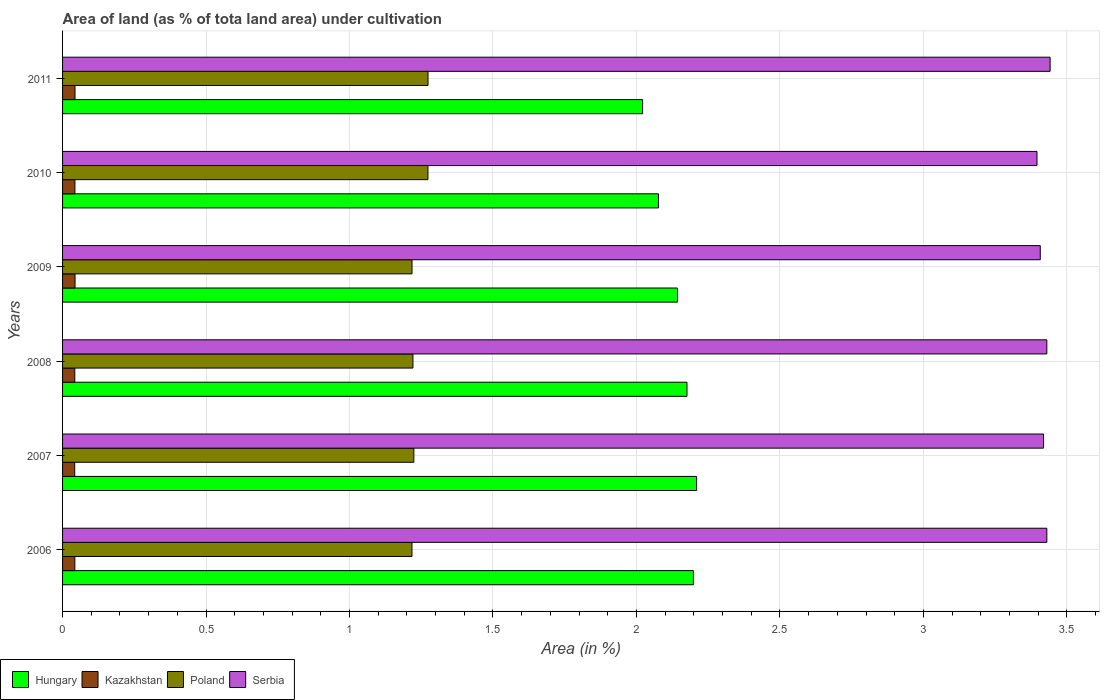How many groups of bars are there?
Ensure brevity in your answer.  6. Are the number of bars per tick equal to the number of legend labels?
Make the answer very short. Yes. How many bars are there on the 2nd tick from the top?
Offer a terse response. 4. What is the label of the 2nd group of bars from the top?
Offer a terse response. 2010. In how many cases, is the number of bars for a given year not equal to the number of legend labels?
Your answer should be compact. 0. What is the percentage of land under cultivation in Poland in 2009?
Make the answer very short. 1.22. Across all years, what is the maximum percentage of land under cultivation in Kazakhstan?
Provide a succinct answer. 0.04. Across all years, what is the minimum percentage of land under cultivation in Hungary?
Offer a very short reply. 2.02. In which year was the percentage of land under cultivation in Hungary maximum?
Your response must be concise. 2007. What is the total percentage of land under cultivation in Hungary in the graph?
Offer a terse response. 12.83. What is the difference between the percentage of land under cultivation in Hungary in 2006 and that in 2009?
Provide a short and direct response. 0.06. What is the difference between the percentage of land under cultivation in Serbia in 2006 and the percentage of land under cultivation in Kazakhstan in 2007?
Your response must be concise. 3.39. What is the average percentage of land under cultivation in Poland per year?
Your response must be concise. 1.24. In the year 2007, what is the difference between the percentage of land under cultivation in Poland and percentage of land under cultivation in Kazakhstan?
Your answer should be compact. 1.18. In how many years, is the percentage of land under cultivation in Kazakhstan greater than 0.5 %?
Your response must be concise. 0. What is the ratio of the percentage of land under cultivation in Serbia in 2008 to that in 2010?
Make the answer very short. 1.01. Is the difference between the percentage of land under cultivation in Poland in 2006 and 2009 greater than the difference between the percentage of land under cultivation in Kazakhstan in 2006 and 2009?
Your answer should be compact. Yes. What is the difference between the highest and the second highest percentage of land under cultivation in Kazakhstan?
Provide a short and direct response. 7.408230544130034e-5. What is the difference between the highest and the lowest percentage of land under cultivation in Serbia?
Ensure brevity in your answer.  0.05. Is the sum of the percentage of land under cultivation in Hungary in 2007 and 2008 greater than the maximum percentage of land under cultivation in Poland across all years?
Your answer should be very brief. Yes. What does the 2nd bar from the top in 2007 represents?
Make the answer very short. Poland. What does the 1st bar from the bottom in 2008 represents?
Ensure brevity in your answer.  Hungary. Is it the case that in every year, the sum of the percentage of land under cultivation in Kazakhstan and percentage of land under cultivation in Serbia is greater than the percentage of land under cultivation in Hungary?
Make the answer very short. Yes. How many years are there in the graph?
Give a very brief answer. 6. Does the graph contain any zero values?
Provide a succinct answer. No. How many legend labels are there?
Offer a terse response. 4. How are the legend labels stacked?
Give a very brief answer. Horizontal. What is the title of the graph?
Offer a very short reply. Area of land (as % of tota land area) under cultivation. What is the label or title of the X-axis?
Keep it short and to the point. Area (in %). What is the Area (in %) of Hungary in 2006?
Your answer should be very brief. 2.2. What is the Area (in %) in Kazakhstan in 2006?
Provide a short and direct response. 0.04. What is the Area (in %) of Poland in 2006?
Keep it short and to the point. 1.22. What is the Area (in %) in Serbia in 2006?
Offer a very short reply. 3.43. What is the Area (in %) of Hungary in 2007?
Offer a very short reply. 2.21. What is the Area (in %) of Kazakhstan in 2007?
Provide a short and direct response. 0.04. What is the Area (in %) of Poland in 2007?
Your response must be concise. 1.22. What is the Area (in %) of Serbia in 2007?
Your answer should be compact. 3.42. What is the Area (in %) in Hungary in 2008?
Your answer should be compact. 2.18. What is the Area (in %) of Kazakhstan in 2008?
Make the answer very short. 0.04. What is the Area (in %) in Poland in 2008?
Your answer should be very brief. 1.22. What is the Area (in %) of Serbia in 2008?
Offer a terse response. 3.43. What is the Area (in %) of Hungary in 2009?
Your answer should be compact. 2.14. What is the Area (in %) of Kazakhstan in 2009?
Offer a terse response. 0.04. What is the Area (in %) of Poland in 2009?
Provide a succinct answer. 1.22. What is the Area (in %) of Serbia in 2009?
Your response must be concise. 3.41. What is the Area (in %) of Hungary in 2010?
Make the answer very short. 2.08. What is the Area (in %) in Kazakhstan in 2010?
Your response must be concise. 0.04. What is the Area (in %) of Poland in 2010?
Your response must be concise. 1.27. What is the Area (in %) in Serbia in 2010?
Keep it short and to the point. 3.4. What is the Area (in %) in Hungary in 2011?
Offer a very short reply. 2.02. What is the Area (in %) in Kazakhstan in 2011?
Keep it short and to the point. 0.04. What is the Area (in %) of Poland in 2011?
Make the answer very short. 1.27. What is the Area (in %) in Serbia in 2011?
Provide a short and direct response. 3.44. Across all years, what is the maximum Area (in %) in Hungary?
Give a very brief answer. 2.21. Across all years, what is the maximum Area (in %) in Kazakhstan?
Provide a short and direct response. 0.04. Across all years, what is the maximum Area (in %) in Poland?
Ensure brevity in your answer.  1.27. Across all years, what is the maximum Area (in %) of Serbia?
Your answer should be very brief. 3.44. Across all years, what is the minimum Area (in %) of Hungary?
Your response must be concise. 2.02. Across all years, what is the minimum Area (in %) in Kazakhstan?
Provide a short and direct response. 0.04. Across all years, what is the minimum Area (in %) of Poland?
Your answer should be very brief. 1.22. Across all years, what is the minimum Area (in %) of Serbia?
Give a very brief answer. 3.4. What is the total Area (in %) in Hungary in the graph?
Your response must be concise. 12.83. What is the total Area (in %) of Kazakhstan in the graph?
Offer a terse response. 0.26. What is the total Area (in %) of Poland in the graph?
Your response must be concise. 7.43. What is the total Area (in %) of Serbia in the graph?
Your response must be concise. 20.52. What is the difference between the Area (in %) of Hungary in 2006 and that in 2007?
Your answer should be compact. -0.01. What is the difference between the Area (in %) of Poland in 2006 and that in 2007?
Your answer should be compact. -0.01. What is the difference between the Area (in %) in Serbia in 2006 and that in 2007?
Give a very brief answer. 0.01. What is the difference between the Area (in %) of Hungary in 2006 and that in 2008?
Keep it short and to the point. 0.02. What is the difference between the Area (in %) of Poland in 2006 and that in 2008?
Make the answer very short. -0. What is the difference between the Area (in %) in Hungary in 2006 and that in 2009?
Make the answer very short. 0.06. What is the difference between the Area (in %) of Kazakhstan in 2006 and that in 2009?
Make the answer very short. -0. What is the difference between the Area (in %) of Poland in 2006 and that in 2009?
Give a very brief answer. -0. What is the difference between the Area (in %) of Serbia in 2006 and that in 2009?
Make the answer very short. 0.02. What is the difference between the Area (in %) in Hungary in 2006 and that in 2010?
Keep it short and to the point. 0.12. What is the difference between the Area (in %) of Kazakhstan in 2006 and that in 2010?
Provide a short and direct response. -0. What is the difference between the Area (in %) of Poland in 2006 and that in 2010?
Ensure brevity in your answer.  -0.06. What is the difference between the Area (in %) of Serbia in 2006 and that in 2010?
Make the answer very short. 0.03. What is the difference between the Area (in %) of Hungary in 2006 and that in 2011?
Your response must be concise. 0.18. What is the difference between the Area (in %) of Kazakhstan in 2006 and that in 2011?
Offer a very short reply. -0. What is the difference between the Area (in %) of Poland in 2006 and that in 2011?
Provide a succinct answer. -0.06. What is the difference between the Area (in %) of Serbia in 2006 and that in 2011?
Keep it short and to the point. -0.01. What is the difference between the Area (in %) in Hungary in 2007 and that in 2008?
Your answer should be compact. 0.03. What is the difference between the Area (in %) in Kazakhstan in 2007 and that in 2008?
Provide a succinct answer. -0. What is the difference between the Area (in %) in Poland in 2007 and that in 2008?
Ensure brevity in your answer.  0. What is the difference between the Area (in %) in Serbia in 2007 and that in 2008?
Your answer should be compact. -0.01. What is the difference between the Area (in %) in Hungary in 2007 and that in 2009?
Keep it short and to the point. 0.07. What is the difference between the Area (in %) of Kazakhstan in 2007 and that in 2009?
Provide a succinct answer. -0. What is the difference between the Area (in %) of Poland in 2007 and that in 2009?
Offer a terse response. 0.01. What is the difference between the Area (in %) of Serbia in 2007 and that in 2009?
Give a very brief answer. 0.01. What is the difference between the Area (in %) in Hungary in 2007 and that in 2010?
Your answer should be very brief. 0.13. What is the difference between the Area (in %) of Kazakhstan in 2007 and that in 2010?
Offer a very short reply. -0. What is the difference between the Area (in %) of Poland in 2007 and that in 2010?
Make the answer very short. -0.05. What is the difference between the Area (in %) of Serbia in 2007 and that in 2010?
Your answer should be compact. 0.02. What is the difference between the Area (in %) of Hungary in 2007 and that in 2011?
Keep it short and to the point. 0.19. What is the difference between the Area (in %) in Kazakhstan in 2007 and that in 2011?
Provide a short and direct response. -0. What is the difference between the Area (in %) in Poland in 2007 and that in 2011?
Keep it short and to the point. -0.05. What is the difference between the Area (in %) of Serbia in 2007 and that in 2011?
Make the answer very short. -0.02. What is the difference between the Area (in %) of Hungary in 2008 and that in 2009?
Provide a succinct answer. 0.03. What is the difference between the Area (in %) of Kazakhstan in 2008 and that in 2009?
Keep it short and to the point. -0. What is the difference between the Area (in %) of Poland in 2008 and that in 2009?
Your response must be concise. 0. What is the difference between the Area (in %) in Serbia in 2008 and that in 2009?
Give a very brief answer. 0.02. What is the difference between the Area (in %) of Hungary in 2008 and that in 2010?
Keep it short and to the point. 0.1. What is the difference between the Area (in %) in Kazakhstan in 2008 and that in 2010?
Give a very brief answer. -0. What is the difference between the Area (in %) of Poland in 2008 and that in 2010?
Give a very brief answer. -0.05. What is the difference between the Area (in %) of Serbia in 2008 and that in 2010?
Offer a very short reply. 0.03. What is the difference between the Area (in %) in Hungary in 2008 and that in 2011?
Offer a very short reply. 0.15. What is the difference between the Area (in %) of Kazakhstan in 2008 and that in 2011?
Your answer should be very brief. -0. What is the difference between the Area (in %) of Poland in 2008 and that in 2011?
Make the answer very short. -0.05. What is the difference between the Area (in %) of Serbia in 2008 and that in 2011?
Provide a short and direct response. -0.01. What is the difference between the Area (in %) in Hungary in 2009 and that in 2010?
Provide a short and direct response. 0.07. What is the difference between the Area (in %) of Poland in 2009 and that in 2010?
Your answer should be compact. -0.06. What is the difference between the Area (in %) in Serbia in 2009 and that in 2010?
Offer a terse response. 0.01. What is the difference between the Area (in %) of Hungary in 2009 and that in 2011?
Give a very brief answer. 0.12. What is the difference between the Area (in %) in Poland in 2009 and that in 2011?
Your response must be concise. -0.06. What is the difference between the Area (in %) in Serbia in 2009 and that in 2011?
Make the answer very short. -0.03. What is the difference between the Area (in %) in Hungary in 2010 and that in 2011?
Offer a very short reply. 0.06. What is the difference between the Area (in %) in Kazakhstan in 2010 and that in 2011?
Make the answer very short. -0. What is the difference between the Area (in %) of Poland in 2010 and that in 2011?
Provide a succinct answer. -0. What is the difference between the Area (in %) of Serbia in 2010 and that in 2011?
Provide a succinct answer. -0.05. What is the difference between the Area (in %) of Hungary in 2006 and the Area (in %) of Kazakhstan in 2007?
Give a very brief answer. 2.16. What is the difference between the Area (in %) of Hungary in 2006 and the Area (in %) of Poland in 2007?
Make the answer very short. 0.97. What is the difference between the Area (in %) of Hungary in 2006 and the Area (in %) of Serbia in 2007?
Provide a short and direct response. -1.22. What is the difference between the Area (in %) in Kazakhstan in 2006 and the Area (in %) in Poland in 2007?
Provide a short and direct response. -1.18. What is the difference between the Area (in %) in Kazakhstan in 2006 and the Area (in %) in Serbia in 2007?
Your answer should be very brief. -3.38. What is the difference between the Area (in %) of Poland in 2006 and the Area (in %) of Serbia in 2007?
Your response must be concise. -2.2. What is the difference between the Area (in %) in Hungary in 2006 and the Area (in %) in Kazakhstan in 2008?
Give a very brief answer. 2.16. What is the difference between the Area (in %) of Hungary in 2006 and the Area (in %) of Poland in 2008?
Your answer should be compact. 0.98. What is the difference between the Area (in %) of Hungary in 2006 and the Area (in %) of Serbia in 2008?
Offer a very short reply. -1.23. What is the difference between the Area (in %) of Kazakhstan in 2006 and the Area (in %) of Poland in 2008?
Your answer should be compact. -1.18. What is the difference between the Area (in %) of Kazakhstan in 2006 and the Area (in %) of Serbia in 2008?
Your answer should be very brief. -3.39. What is the difference between the Area (in %) of Poland in 2006 and the Area (in %) of Serbia in 2008?
Offer a terse response. -2.21. What is the difference between the Area (in %) in Hungary in 2006 and the Area (in %) in Kazakhstan in 2009?
Ensure brevity in your answer.  2.15. What is the difference between the Area (in %) in Hungary in 2006 and the Area (in %) in Poland in 2009?
Keep it short and to the point. 0.98. What is the difference between the Area (in %) in Hungary in 2006 and the Area (in %) in Serbia in 2009?
Offer a very short reply. -1.21. What is the difference between the Area (in %) of Kazakhstan in 2006 and the Area (in %) of Poland in 2009?
Your answer should be very brief. -1.18. What is the difference between the Area (in %) of Kazakhstan in 2006 and the Area (in %) of Serbia in 2009?
Your answer should be very brief. -3.36. What is the difference between the Area (in %) in Poland in 2006 and the Area (in %) in Serbia in 2009?
Your answer should be very brief. -2.19. What is the difference between the Area (in %) of Hungary in 2006 and the Area (in %) of Kazakhstan in 2010?
Your answer should be compact. 2.16. What is the difference between the Area (in %) in Hungary in 2006 and the Area (in %) in Poland in 2010?
Offer a very short reply. 0.93. What is the difference between the Area (in %) in Hungary in 2006 and the Area (in %) in Serbia in 2010?
Ensure brevity in your answer.  -1.2. What is the difference between the Area (in %) in Kazakhstan in 2006 and the Area (in %) in Poland in 2010?
Your answer should be very brief. -1.23. What is the difference between the Area (in %) in Kazakhstan in 2006 and the Area (in %) in Serbia in 2010?
Your answer should be compact. -3.35. What is the difference between the Area (in %) of Poland in 2006 and the Area (in %) of Serbia in 2010?
Make the answer very short. -2.18. What is the difference between the Area (in %) in Hungary in 2006 and the Area (in %) in Kazakhstan in 2011?
Give a very brief answer. 2.15. What is the difference between the Area (in %) of Hungary in 2006 and the Area (in %) of Poland in 2011?
Ensure brevity in your answer.  0.92. What is the difference between the Area (in %) of Hungary in 2006 and the Area (in %) of Serbia in 2011?
Provide a succinct answer. -1.24. What is the difference between the Area (in %) in Kazakhstan in 2006 and the Area (in %) in Poland in 2011?
Your response must be concise. -1.23. What is the difference between the Area (in %) in Kazakhstan in 2006 and the Area (in %) in Serbia in 2011?
Provide a short and direct response. -3.4. What is the difference between the Area (in %) of Poland in 2006 and the Area (in %) of Serbia in 2011?
Offer a terse response. -2.22. What is the difference between the Area (in %) in Hungary in 2007 and the Area (in %) in Kazakhstan in 2008?
Your answer should be very brief. 2.17. What is the difference between the Area (in %) of Hungary in 2007 and the Area (in %) of Poland in 2008?
Offer a very short reply. 0.99. What is the difference between the Area (in %) of Hungary in 2007 and the Area (in %) of Serbia in 2008?
Your response must be concise. -1.22. What is the difference between the Area (in %) of Kazakhstan in 2007 and the Area (in %) of Poland in 2008?
Provide a succinct answer. -1.18. What is the difference between the Area (in %) in Kazakhstan in 2007 and the Area (in %) in Serbia in 2008?
Make the answer very short. -3.39. What is the difference between the Area (in %) of Poland in 2007 and the Area (in %) of Serbia in 2008?
Your answer should be very brief. -2.21. What is the difference between the Area (in %) of Hungary in 2007 and the Area (in %) of Kazakhstan in 2009?
Offer a very short reply. 2.17. What is the difference between the Area (in %) in Hungary in 2007 and the Area (in %) in Serbia in 2009?
Your response must be concise. -1.2. What is the difference between the Area (in %) of Kazakhstan in 2007 and the Area (in %) of Poland in 2009?
Ensure brevity in your answer.  -1.18. What is the difference between the Area (in %) in Kazakhstan in 2007 and the Area (in %) in Serbia in 2009?
Provide a succinct answer. -3.36. What is the difference between the Area (in %) in Poland in 2007 and the Area (in %) in Serbia in 2009?
Your response must be concise. -2.18. What is the difference between the Area (in %) in Hungary in 2007 and the Area (in %) in Kazakhstan in 2010?
Offer a terse response. 2.17. What is the difference between the Area (in %) of Hungary in 2007 and the Area (in %) of Poland in 2010?
Keep it short and to the point. 0.94. What is the difference between the Area (in %) in Hungary in 2007 and the Area (in %) in Serbia in 2010?
Offer a terse response. -1.19. What is the difference between the Area (in %) of Kazakhstan in 2007 and the Area (in %) of Poland in 2010?
Offer a very short reply. -1.23. What is the difference between the Area (in %) of Kazakhstan in 2007 and the Area (in %) of Serbia in 2010?
Provide a short and direct response. -3.35. What is the difference between the Area (in %) in Poland in 2007 and the Area (in %) in Serbia in 2010?
Ensure brevity in your answer.  -2.17. What is the difference between the Area (in %) of Hungary in 2007 and the Area (in %) of Kazakhstan in 2011?
Offer a terse response. 2.17. What is the difference between the Area (in %) of Hungary in 2007 and the Area (in %) of Poland in 2011?
Keep it short and to the point. 0.94. What is the difference between the Area (in %) in Hungary in 2007 and the Area (in %) in Serbia in 2011?
Keep it short and to the point. -1.23. What is the difference between the Area (in %) of Kazakhstan in 2007 and the Area (in %) of Poland in 2011?
Provide a succinct answer. -1.23. What is the difference between the Area (in %) in Kazakhstan in 2007 and the Area (in %) in Serbia in 2011?
Offer a terse response. -3.4. What is the difference between the Area (in %) in Poland in 2007 and the Area (in %) in Serbia in 2011?
Offer a terse response. -2.22. What is the difference between the Area (in %) in Hungary in 2008 and the Area (in %) in Kazakhstan in 2009?
Provide a short and direct response. 2.13. What is the difference between the Area (in %) in Hungary in 2008 and the Area (in %) in Serbia in 2009?
Make the answer very short. -1.23. What is the difference between the Area (in %) in Kazakhstan in 2008 and the Area (in %) in Poland in 2009?
Provide a succinct answer. -1.18. What is the difference between the Area (in %) of Kazakhstan in 2008 and the Area (in %) of Serbia in 2009?
Provide a short and direct response. -3.36. What is the difference between the Area (in %) in Poland in 2008 and the Area (in %) in Serbia in 2009?
Provide a succinct answer. -2.19. What is the difference between the Area (in %) of Hungary in 2008 and the Area (in %) of Kazakhstan in 2010?
Provide a short and direct response. 2.13. What is the difference between the Area (in %) of Hungary in 2008 and the Area (in %) of Poland in 2010?
Provide a short and direct response. 0.9. What is the difference between the Area (in %) of Hungary in 2008 and the Area (in %) of Serbia in 2010?
Provide a short and direct response. -1.22. What is the difference between the Area (in %) of Kazakhstan in 2008 and the Area (in %) of Poland in 2010?
Your response must be concise. -1.23. What is the difference between the Area (in %) in Kazakhstan in 2008 and the Area (in %) in Serbia in 2010?
Provide a short and direct response. -3.35. What is the difference between the Area (in %) in Poland in 2008 and the Area (in %) in Serbia in 2010?
Ensure brevity in your answer.  -2.17. What is the difference between the Area (in %) in Hungary in 2008 and the Area (in %) in Kazakhstan in 2011?
Offer a very short reply. 2.13. What is the difference between the Area (in %) in Hungary in 2008 and the Area (in %) in Poland in 2011?
Ensure brevity in your answer.  0.9. What is the difference between the Area (in %) of Hungary in 2008 and the Area (in %) of Serbia in 2011?
Your response must be concise. -1.27. What is the difference between the Area (in %) in Kazakhstan in 2008 and the Area (in %) in Poland in 2011?
Your response must be concise. -1.23. What is the difference between the Area (in %) in Kazakhstan in 2008 and the Area (in %) in Serbia in 2011?
Your answer should be very brief. -3.4. What is the difference between the Area (in %) in Poland in 2008 and the Area (in %) in Serbia in 2011?
Offer a terse response. -2.22. What is the difference between the Area (in %) of Hungary in 2009 and the Area (in %) of Kazakhstan in 2010?
Offer a terse response. 2.1. What is the difference between the Area (in %) of Hungary in 2009 and the Area (in %) of Poland in 2010?
Your answer should be compact. 0.87. What is the difference between the Area (in %) in Hungary in 2009 and the Area (in %) in Serbia in 2010?
Offer a terse response. -1.25. What is the difference between the Area (in %) in Kazakhstan in 2009 and the Area (in %) in Poland in 2010?
Your answer should be very brief. -1.23. What is the difference between the Area (in %) of Kazakhstan in 2009 and the Area (in %) of Serbia in 2010?
Provide a short and direct response. -3.35. What is the difference between the Area (in %) of Poland in 2009 and the Area (in %) of Serbia in 2010?
Ensure brevity in your answer.  -2.18. What is the difference between the Area (in %) in Hungary in 2009 and the Area (in %) in Kazakhstan in 2011?
Provide a short and direct response. 2.1. What is the difference between the Area (in %) in Hungary in 2009 and the Area (in %) in Poland in 2011?
Keep it short and to the point. 0.87. What is the difference between the Area (in %) in Hungary in 2009 and the Area (in %) in Serbia in 2011?
Make the answer very short. -1.3. What is the difference between the Area (in %) in Kazakhstan in 2009 and the Area (in %) in Poland in 2011?
Give a very brief answer. -1.23. What is the difference between the Area (in %) in Kazakhstan in 2009 and the Area (in %) in Serbia in 2011?
Keep it short and to the point. -3.4. What is the difference between the Area (in %) of Poland in 2009 and the Area (in %) of Serbia in 2011?
Ensure brevity in your answer.  -2.22. What is the difference between the Area (in %) in Hungary in 2010 and the Area (in %) in Kazakhstan in 2011?
Offer a very short reply. 2.03. What is the difference between the Area (in %) in Hungary in 2010 and the Area (in %) in Poland in 2011?
Your answer should be compact. 0.8. What is the difference between the Area (in %) of Hungary in 2010 and the Area (in %) of Serbia in 2011?
Give a very brief answer. -1.36. What is the difference between the Area (in %) in Kazakhstan in 2010 and the Area (in %) in Poland in 2011?
Ensure brevity in your answer.  -1.23. What is the difference between the Area (in %) in Kazakhstan in 2010 and the Area (in %) in Serbia in 2011?
Keep it short and to the point. -3.4. What is the difference between the Area (in %) in Poland in 2010 and the Area (in %) in Serbia in 2011?
Offer a terse response. -2.17. What is the average Area (in %) of Hungary per year?
Give a very brief answer. 2.14. What is the average Area (in %) of Kazakhstan per year?
Your response must be concise. 0.04. What is the average Area (in %) in Poland per year?
Offer a very short reply. 1.24. What is the average Area (in %) of Serbia per year?
Offer a terse response. 3.42. In the year 2006, what is the difference between the Area (in %) of Hungary and Area (in %) of Kazakhstan?
Your response must be concise. 2.16. In the year 2006, what is the difference between the Area (in %) in Hungary and Area (in %) in Poland?
Keep it short and to the point. 0.98. In the year 2006, what is the difference between the Area (in %) in Hungary and Area (in %) in Serbia?
Keep it short and to the point. -1.23. In the year 2006, what is the difference between the Area (in %) in Kazakhstan and Area (in %) in Poland?
Offer a very short reply. -1.17. In the year 2006, what is the difference between the Area (in %) in Kazakhstan and Area (in %) in Serbia?
Offer a terse response. -3.39. In the year 2006, what is the difference between the Area (in %) in Poland and Area (in %) in Serbia?
Offer a very short reply. -2.21. In the year 2007, what is the difference between the Area (in %) of Hungary and Area (in %) of Kazakhstan?
Your answer should be compact. 2.17. In the year 2007, what is the difference between the Area (in %) in Hungary and Area (in %) in Poland?
Give a very brief answer. 0.99. In the year 2007, what is the difference between the Area (in %) in Hungary and Area (in %) in Serbia?
Offer a terse response. -1.21. In the year 2007, what is the difference between the Area (in %) of Kazakhstan and Area (in %) of Poland?
Make the answer very short. -1.18. In the year 2007, what is the difference between the Area (in %) in Kazakhstan and Area (in %) in Serbia?
Your answer should be compact. -3.38. In the year 2007, what is the difference between the Area (in %) of Poland and Area (in %) of Serbia?
Ensure brevity in your answer.  -2.19. In the year 2008, what is the difference between the Area (in %) of Hungary and Area (in %) of Kazakhstan?
Offer a terse response. 2.13. In the year 2008, what is the difference between the Area (in %) of Hungary and Area (in %) of Poland?
Make the answer very short. 0.96. In the year 2008, what is the difference between the Area (in %) of Hungary and Area (in %) of Serbia?
Provide a succinct answer. -1.25. In the year 2008, what is the difference between the Area (in %) of Kazakhstan and Area (in %) of Poland?
Ensure brevity in your answer.  -1.18. In the year 2008, what is the difference between the Area (in %) of Kazakhstan and Area (in %) of Serbia?
Offer a terse response. -3.39. In the year 2008, what is the difference between the Area (in %) in Poland and Area (in %) in Serbia?
Offer a very short reply. -2.21. In the year 2009, what is the difference between the Area (in %) in Hungary and Area (in %) in Kazakhstan?
Provide a succinct answer. 2.1. In the year 2009, what is the difference between the Area (in %) of Hungary and Area (in %) of Poland?
Give a very brief answer. 0.93. In the year 2009, what is the difference between the Area (in %) in Hungary and Area (in %) in Serbia?
Give a very brief answer. -1.26. In the year 2009, what is the difference between the Area (in %) of Kazakhstan and Area (in %) of Poland?
Your answer should be very brief. -1.17. In the year 2009, what is the difference between the Area (in %) of Kazakhstan and Area (in %) of Serbia?
Offer a very short reply. -3.36. In the year 2009, what is the difference between the Area (in %) in Poland and Area (in %) in Serbia?
Make the answer very short. -2.19. In the year 2010, what is the difference between the Area (in %) in Hungary and Area (in %) in Kazakhstan?
Ensure brevity in your answer.  2.03. In the year 2010, what is the difference between the Area (in %) of Hungary and Area (in %) of Poland?
Offer a terse response. 0.8. In the year 2010, what is the difference between the Area (in %) in Hungary and Area (in %) in Serbia?
Your answer should be compact. -1.32. In the year 2010, what is the difference between the Area (in %) in Kazakhstan and Area (in %) in Poland?
Ensure brevity in your answer.  -1.23. In the year 2010, what is the difference between the Area (in %) of Kazakhstan and Area (in %) of Serbia?
Make the answer very short. -3.35. In the year 2010, what is the difference between the Area (in %) of Poland and Area (in %) of Serbia?
Provide a short and direct response. -2.12. In the year 2011, what is the difference between the Area (in %) of Hungary and Area (in %) of Kazakhstan?
Give a very brief answer. 1.98. In the year 2011, what is the difference between the Area (in %) of Hungary and Area (in %) of Poland?
Offer a very short reply. 0.75. In the year 2011, what is the difference between the Area (in %) in Hungary and Area (in %) in Serbia?
Provide a short and direct response. -1.42. In the year 2011, what is the difference between the Area (in %) in Kazakhstan and Area (in %) in Poland?
Give a very brief answer. -1.23. In the year 2011, what is the difference between the Area (in %) of Kazakhstan and Area (in %) of Serbia?
Make the answer very short. -3.4. In the year 2011, what is the difference between the Area (in %) of Poland and Area (in %) of Serbia?
Make the answer very short. -2.17. What is the ratio of the Area (in %) in Hungary in 2006 to that in 2007?
Your answer should be very brief. 0.99. What is the ratio of the Area (in %) in Kazakhstan in 2006 to that in 2007?
Give a very brief answer. 1.01. What is the ratio of the Area (in %) in Serbia in 2006 to that in 2007?
Your answer should be compact. 1. What is the ratio of the Area (in %) in Hungary in 2006 to that in 2008?
Ensure brevity in your answer.  1.01. What is the ratio of the Area (in %) of Kazakhstan in 2006 to that in 2008?
Keep it short and to the point. 1. What is the ratio of the Area (in %) in Poland in 2006 to that in 2008?
Keep it short and to the point. 1. What is the ratio of the Area (in %) of Hungary in 2006 to that in 2009?
Offer a very short reply. 1.03. What is the ratio of the Area (in %) in Kazakhstan in 2006 to that in 2009?
Ensure brevity in your answer.  0.98. What is the ratio of the Area (in %) in Hungary in 2006 to that in 2010?
Offer a terse response. 1.06. What is the ratio of the Area (in %) of Poland in 2006 to that in 2010?
Give a very brief answer. 0.96. What is the ratio of the Area (in %) of Serbia in 2006 to that in 2010?
Give a very brief answer. 1.01. What is the ratio of the Area (in %) of Hungary in 2006 to that in 2011?
Offer a very short reply. 1.09. What is the ratio of the Area (in %) in Kazakhstan in 2006 to that in 2011?
Provide a succinct answer. 0.99. What is the ratio of the Area (in %) in Poland in 2006 to that in 2011?
Your answer should be compact. 0.96. What is the ratio of the Area (in %) of Serbia in 2006 to that in 2011?
Provide a short and direct response. 1. What is the ratio of the Area (in %) in Hungary in 2007 to that in 2008?
Ensure brevity in your answer.  1.02. What is the ratio of the Area (in %) in Serbia in 2007 to that in 2008?
Provide a succinct answer. 1. What is the ratio of the Area (in %) in Hungary in 2007 to that in 2009?
Make the answer very short. 1.03. What is the ratio of the Area (in %) in Kazakhstan in 2007 to that in 2009?
Keep it short and to the point. 0.97. What is the ratio of the Area (in %) in Poland in 2007 to that in 2009?
Keep it short and to the point. 1.01. What is the ratio of the Area (in %) in Hungary in 2007 to that in 2010?
Give a very brief answer. 1.06. What is the ratio of the Area (in %) of Kazakhstan in 2007 to that in 2010?
Your response must be concise. 0.98. What is the ratio of the Area (in %) of Poland in 2007 to that in 2010?
Provide a succinct answer. 0.96. What is the ratio of the Area (in %) of Hungary in 2007 to that in 2011?
Your response must be concise. 1.09. What is the ratio of the Area (in %) of Kazakhstan in 2007 to that in 2011?
Give a very brief answer. 0.98. What is the ratio of the Area (in %) of Poland in 2007 to that in 2011?
Ensure brevity in your answer.  0.96. What is the ratio of the Area (in %) in Serbia in 2007 to that in 2011?
Your response must be concise. 0.99. What is the ratio of the Area (in %) of Hungary in 2008 to that in 2009?
Give a very brief answer. 1.02. What is the ratio of the Area (in %) of Kazakhstan in 2008 to that in 2009?
Your answer should be very brief. 0.98. What is the ratio of the Area (in %) in Hungary in 2008 to that in 2010?
Your response must be concise. 1.05. What is the ratio of the Area (in %) of Kazakhstan in 2008 to that in 2010?
Offer a terse response. 0.99. What is the ratio of the Area (in %) in Poland in 2008 to that in 2010?
Your response must be concise. 0.96. What is the ratio of the Area (in %) of Serbia in 2008 to that in 2010?
Offer a very short reply. 1.01. What is the ratio of the Area (in %) in Hungary in 2008 to that in 2011?
Make the answer very short. 1.08. What is the ratio of the Area (in %) of Kazakhstan in 2008 to that in 2011?
Your response must be concise. 0.98. What is the ratio of the Area (in %) of Poland in 2008 to that in 2011?
Make the answer very short. 0.96. What is the ratio of the Area (in %) in Serbia in 2008 to that in 2011?
Give a very brief answer. 1. What is the ratio of the Area (in %) in Hungary in 2009 to that in 2010?
Offer a terse response. 1.03. What is the ratio of the Area (in %) in Kazakhstan in 2009 to that in 2010?
Your response must be concise. 1.01. What is the ratio of the Area (in %) in Poland in 2009 to that in 2010?
Offer a terse response. 0.96. What is the ratio of the Area (in %) in Hungary in 2009 to that in 2011?
Offer a very short reply. 1.06. What is the ratio of the Area (in %) of Poland in 2009 to that in 2011?
Give a very brief answer. 0.96. What is the ratio of the Area (in %) in Serbia in 2009 to that in 2011?
Keep it short and to the point. 0.99. What is the ratio of the Area (in %) of Hungary in 2010 to that in 2011?
Provide a succinct answer. 1.03. What is the ratio of the Area (in %) in Poland in 2010 to that in 2011?
Offer a very short reply. 1. What is the ratio of the Area (in %) of Serbia in 2010 to that in 2011?
Offer a very short reply. 0.99. What is the difference between the highest and the second highest Area (in %) in Hungary?
Give a very brief answer. 0.01. What is the difference between the highest and the second highest Area (in %) of Kazakhstan?
Offer a very short reply. 0. What is the difference between the highest and the second highest Area (in %) in Serbia?
Your answer should be compact. 0.01. What is the difference between the highest and the lowest Area (in %) of Hungary?
Offer a terse response. 0.19. What is the difference between the highest and the lowest Area (in %) of Kazakhstan?
Provide a succinct answer. 0. What is the difference between the highest and the lowest Area (in %) of Poland?
Your response must be concise. 0.06. What is the difference between the highest and the lowest Area (in %) of Serbia?
Offer a terse response. 0.05. 